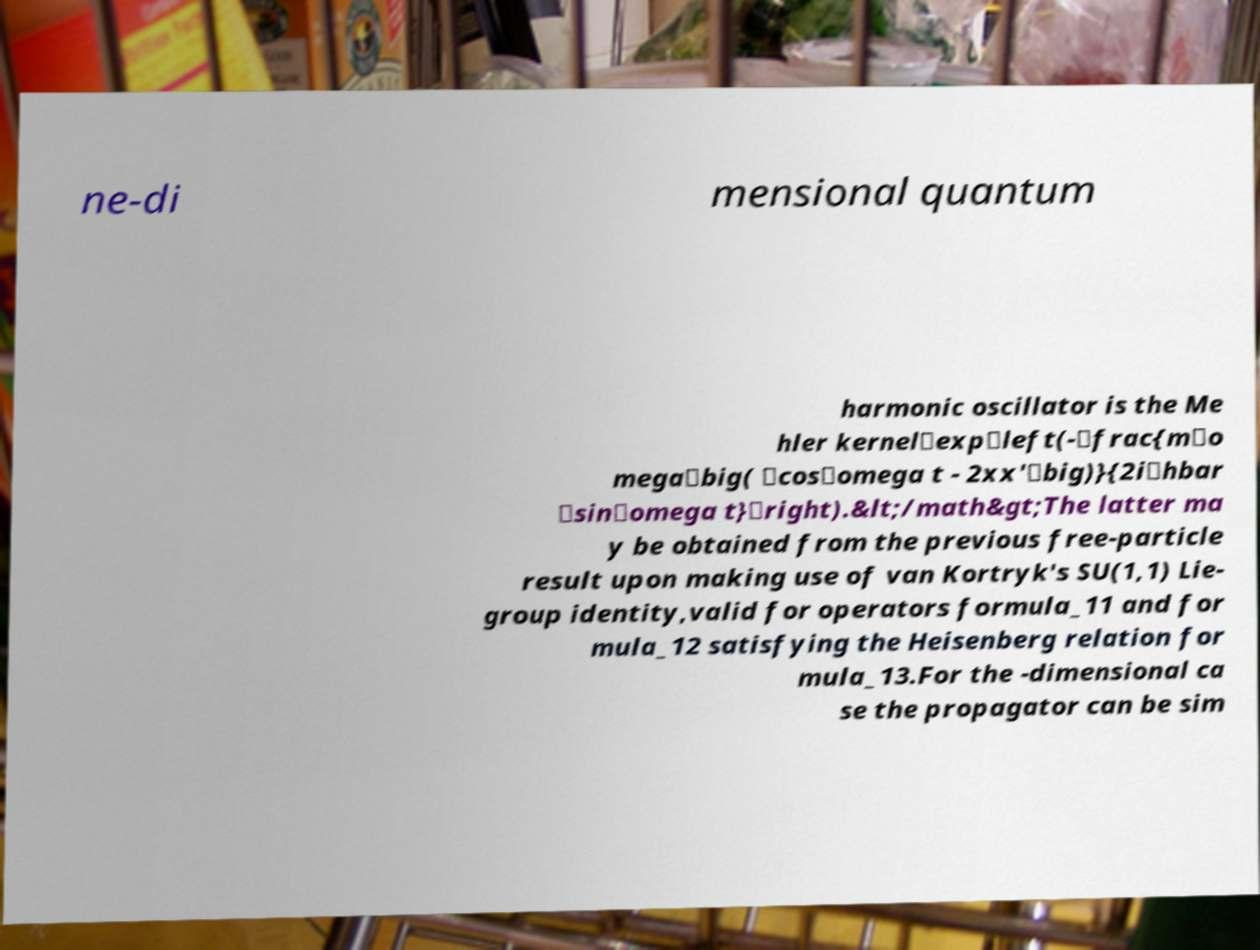Could you assist in decoding the text presented in this image and type it out clearly? ne-di mensional quantum harmonic oscillator is the Me hler kernel\exp\left(-\frac{m\o mega\big( \cos\omega t - 2xx'\big)}{2i\hbar \sin\omega t}\right).&lt;/math&gt;The latter ma y be obtained from the previous free-particle result upon making use of van Kortryk's SU(1,1) Lie- group identity,valid for operators formula_11 and for mula_12 satisfying the Heisenberg relation for mula_13.For the -dimensional ca se the propagator can be sim 